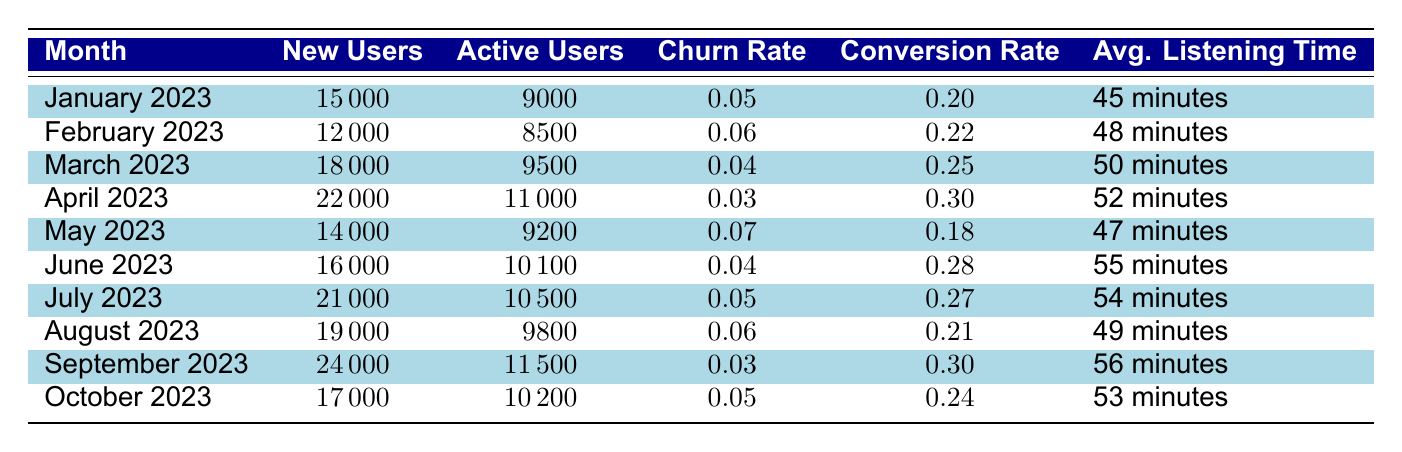What was the churn rate in April 2023? The table shows that in April 2023, the churn rate is listed as 0.03.
Answer: 0.03 How many new users were acquired in March 2023? According to the table, in March 2023, the number of new users is 18000.
Answer: 18000 What is the average listening time in June 2023? The table indicates that in June 2023, the average listening time is 55 minutes.
Answer: 55 minutes What was the conversion rate for May 2023? The conversion rate for May 2023 is presented in the table as 0.18.
Answer: 0.18 Which month had the highest number of active users? By comparing the active users for each month, April 2023 had the highest with 11000 active users.
Answer: April 2023 How many total new users were acquired from January to March 2023? The total new users from January (15000), February (12000), and March (18000) are calculated by adding them together: 15000 + 12000 + 18000 = 45000.
Answer: 45000 Was the churn rate lower in September 2023 compared to February 2023? In September 2023, the churn rate is 0.03, while in February 2023, it is 0.06. Since 0.03 is lower than 0.06, the answer is yes.
Answer: Yes How did the average listening time change from January 2023 to September 2023? The average listening time in January 2023 is 45 minutes, and in September 2023 it is 56 minutes. The change can be found by calculating: 56 - 45 = 11 minutes. This indicates an increase of 11 minutes.
Answer: Increased by 11 minutes In which month did the highest conversion rate occur? By looking at the conversion rates listed, April 2023 has the highest conversion rate of 0.30.
Answer: April 2023 What percentage of new users converted to active users in July 2023? For July 2023, the number of new users is 21000 and the number of active users is 10500. The conversion can be calculated as: (10500 / 21000) * 100 = 50%.
Answer: 50% 